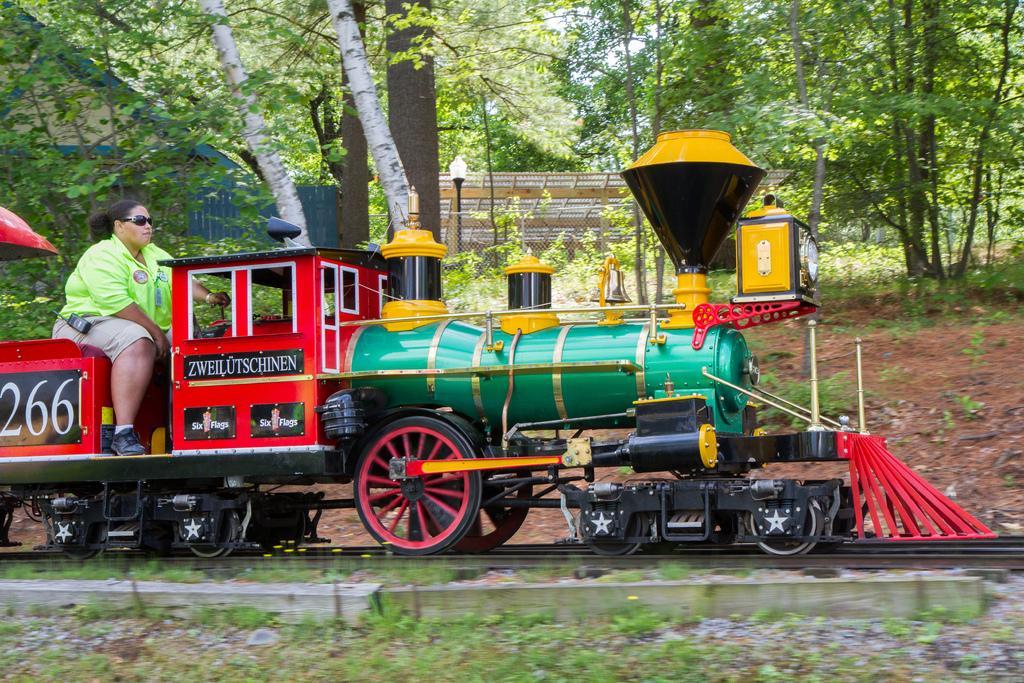In one or two sentences, can you explain what this image depicts? In this image I can see a train on the track and the train is in green, red and yellow color. I can also a person sitting on the train wearing green shirt, cream short. Background I can see few light poles, a building in cream color, trees in green color and the sky is in white color. 